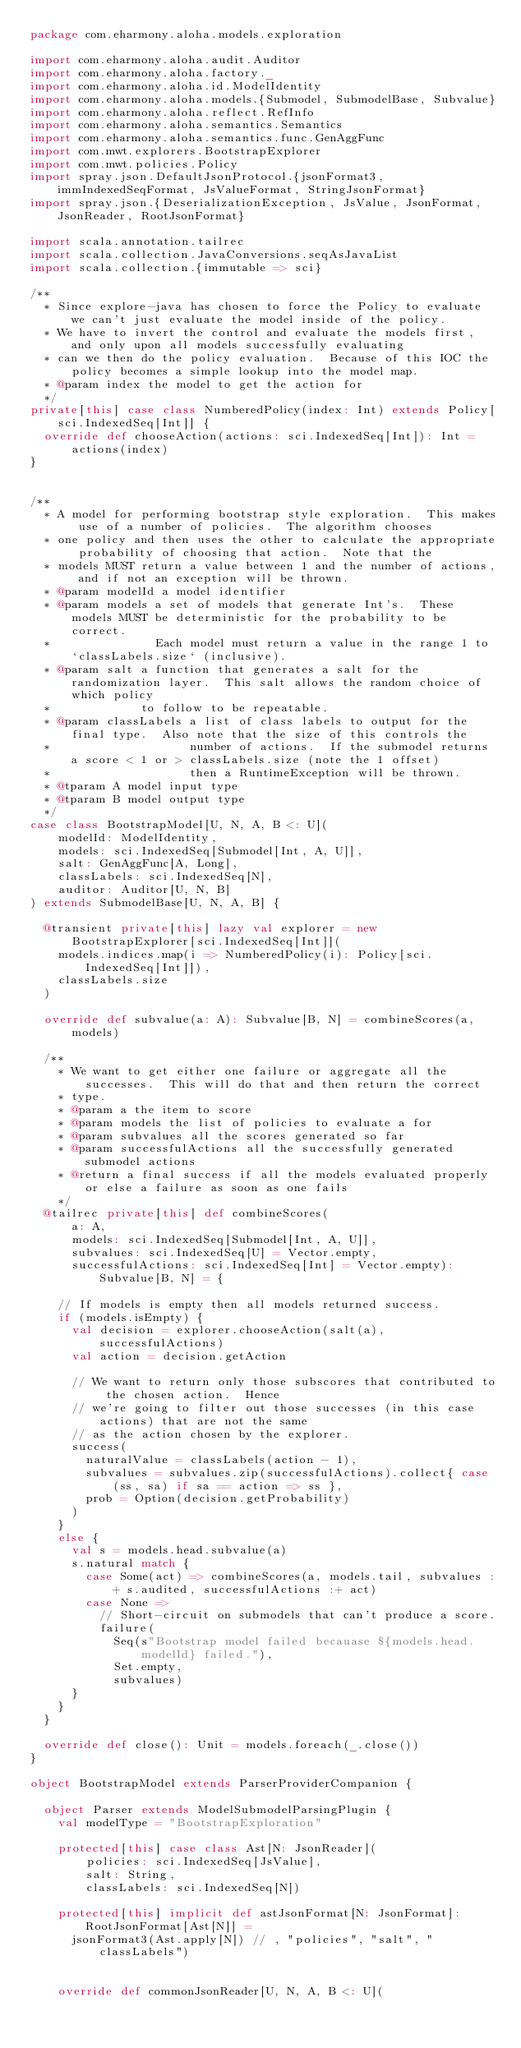Convert code to text. <code><loc_0><loc_0><loc_500><loc_500><_Scala_>package com.eharmony.aloha.models.exploration

import com.eharmony.aloha.audit.Auditor
import com.eharmony.aloha.factory._
import com.eharmony.aloha.id.ModelIdentity
import com.eharmony.aloha.models.{Submodel, SubmodelBase, Subvalue}
import com.eharmony.aloha.reflect.RefInfo
import com.eharmony.aloha.semantics.Semantics
import com.eharmony.aloha.semantics.func.GenAggFunc
import com.mwt.explorers.BootstrapExplorer
import com.mwt.policies.Policy
import spray.json.DefaultJsonProtocol.{jsonFormat3, immIndexedSeqFormat, JsValueFormat, StringJsonFormat}
import spray.json.{DeserializationException, JsValue, JsonFormat, JsonReader, RootJsonFormat}

import scala.annotation.tailrec
import scala.collection.JavaConversions.seqAsJavaList
import scala.collection.{immutable => sci}

/**
  * Since explore-java has chosen to force the Policy to evaluate we can't just evaluate the model inside of the policy.
  * We have to invert the control and evaluate the models first, and only upon all models successfully evaluating
  * can we then do the policy evaluation.  Because of this IOC the policy becomes a simple lookup into the model map.
  * @param index the model to get the action for
  */
private[this] case class NumberedPolicy(index: Int) extends Policy[sci.IndexedSeq[Int]] {
  override def chooseAction(actions: sci.IndexedSeq[Int]): Int = actions(index)
}


/**
  * A model for performing bootstrap style exploration.  This makes use of a number of policies.  The algorithm chooses
  * one policy and then uses the other to calculate the appropriate probability of choosing that action.  Note that the
  * models MUST return a value between 1 and the number of actions, and if not an exception will be thrown.
  * @param modelId a model identifier
  * @param models a set of models that generate Int's.  These models MUST be deterministic for the probability to be correct.
  *               Each model must return a value in the range 1 to `classLabels.size` (inclusive).
  * @param salt a function that generates a salt for the randomization layer.  This salt allows the random choice of which policy
  *             to follow to be repeatable.
  * @param classLabels a list of class labels to output for the final type.  Also note that the size of this controls the
  *                    number of actions.  If the submodel returns a score < 1 or > classLabels.size (note the 1 offset)
  *                    then a RuntimeException will be thrown.
  * @tparam A model input type
  * @tparam B model output type
  */
case class BootstrapModel[U, N, A, B <: U](
    modelId: ModelIdentity,
    models: sci.IndexedSeq[Submodel[Int, A, U]],
    salt: GenAggFunc[A, Long],
    classLabels: sci.IndexedSeq[N],
    auditor: Auditor[U, N, B]
) extends SubmodelBase[U, N, A, B] {

  @transient private[this] lazy val explorer = new BootstrapExplorer[sci.IndexedSeq[Int]](
    models.indices.map(i => NumberedPolicy(i): Policy[sci.IndexedSeq[Int]]),
    classLabels.size
  )

  override def subvalue(a: A): Subvalue[B, N] = combineScores(a, models)

  /**
    * We want to get either one failure or aggregate all the successes.  This will do that and then return the correct
    * type.
    * @param a the item to score
    * @param models the list of policies to evaluate a for
    * @param subvalues all the scores generated so far
    * @param successfulActions all the successfully generated submodel actions
    * @return a final success if all the models evaluated properly or else a failure as soon as one fails
    */
  @tailrec private[this] def combineScores(
      a: A,
      models: sci.IndexedSeq[Submodel[Int, A, U]],
      subvalues: sci.IndexedSeq[U] = Vector.empty,
      successfulActions: sci.IndexedSeq[Int] = Vector.empty): Subvalue[B, N] = {

    // If models is empty then all models returned success.
    if (models.isEmpty) {
      val decision = explorer.chooseAction(salt(a), successfulActions)
      val action = decision.getAction

      // We want to return only those subscores that contributed to the chosen action.  Hence
      // we're going to filter out those successes (in this case actions) that are not the same
      // as the action chosen by the explorer.
      success(
        naturalValue = classLabels(action - 1),
        subvalues = subvalues.zip(successfulActions).collect{ case (ss, sa) if sa == action => ss },
        prob = Option(decision.getProbability)
      )
    }
    else {
      val s = models.head.subvalue(a)
      s.natural match {
        case Some(act) => combineScores(a, models.tail, subvalues :+ s.audited, successfulActions :+ act)
        case None =>
          // Short-circuit on submodels that can't produce a score.
          failure(
            Seq(s"Bootstrap model failed becauase ${models.head.modelId} failed."),
            Set.empty,
            subvalues)
      }
    }
  }

  override def close(): Unit = models.foreach(_.close())
}

object BootstrapModel extends ParserProviderCompanion {

  object Parser extends ModelSubmodelParsingPlugin {
    val modelType = "BootstrapExploration"

    protected[this] case class Ast[N: JsonReader](
        policies: sci.IndexedSeq[JsValue],
        salt: String,
        classLabels: sci.IndexedSeq[N])

    protected[this] implicit def astJsonFormat[N: JsonFormat]: RootJsonFormat[Ast[N]] =
      jsonFormat3(Ast.apply[N]) // , "policies", "salt", "classLabels")


    override def commonJsonReader[U, N, A, B <: U](</code> 